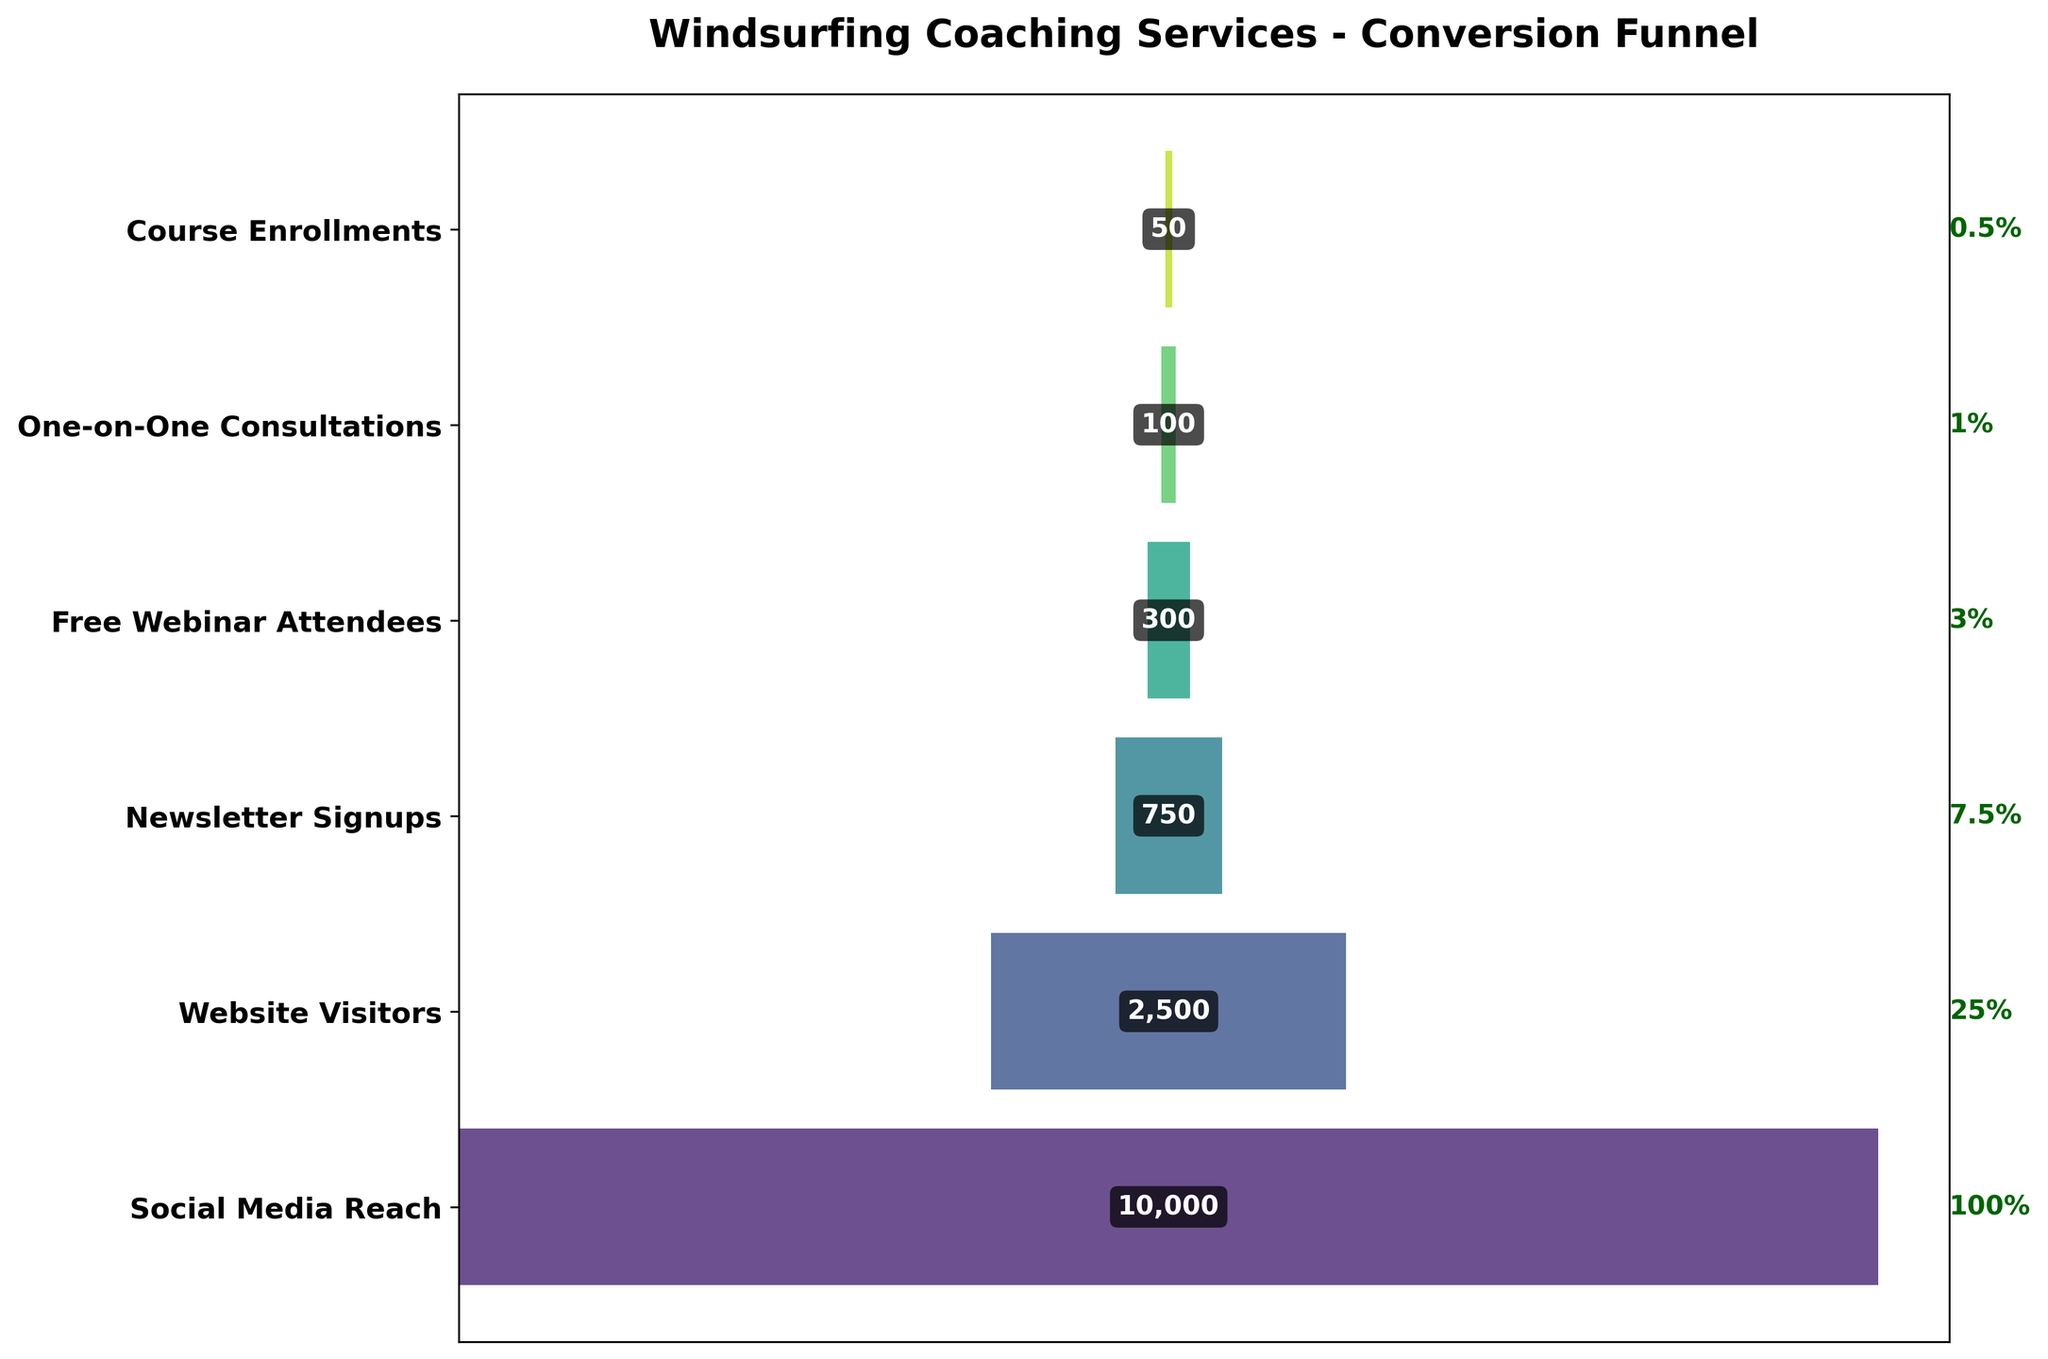What's the total number of participants at the "Website Visitors" stage? We're looking for the participants labeled at the "Website Visitors" stage. According to the chart, it's 2,500.
Answer: 2,500 What percentage of the social media reach proceeded to "Website Visitors"? "Website Visitors" are 2,500 out of the 10,000 "Social Media Reach". The percentage is calculated as (2,500 / 10,000) * 100 = 25%.
Answer: 25% Which stage has the least participants? By scanning the bar lengths and participant numbers, "Course Enrollments" have the least participants at 50.
Answer: Course Enrollments Compare the conversion rate from "Free Webinar Attendees" to "One-on-One Consultations" with the conversion rate from "Newsletter Signups" to "Free Webinar Attendees". Which is higher? Conversion rate from "Free Webinar Attendees" (300) to "One-on-One Consultations" (100) is 100/300 = 33.33%. From "Newsletter Signups" (750) to "Free Webinar Attendees" (300) is 300/750 = 40%. The latter is higher.
Answer: Newsletter Signups to Free Webinar Attendees What is the approximate drop-off rate between "Website Visitors" and "Newsletter Signups"? The drop-off rate can be found by (1 - (750 / 2,500)) * 100 = 70%.
Answer: 70% How many participants do not progress past the "Free Webinar Attendees" stage? Participants not progressing past this stage include those at the "Free Webinar Attendees" minus "One-on-One Consultations". This is 300 - 100 = 200.
Answer: 200 What's the difference in the number of participants between "Website Visitors" and "Free Webinar Attendees"? Subtracting "Free Webinar Attendees" (300) from "Website Visitors" (2,500) gives us 2,500 - 300 = 2,200.
Answer: 2,200 What conversion stage sees a drop below 1,000 participants for the first time? "Newsletter Signups" are the first stage to drop below 1,000 with 750 participants.
Answer: Newsletter Signups What is the title of the funnel chart? The title is located at the top of the chart and reads "Windsurfing Coaching Services - Conversion Funnel".
Answer: Windsurfing Coaching Services - Conversion Funnel Which stage has a conversion rate of 0.5%? Scanning the conversion rate labels, "Course Enrollments" has a 0.5% rate.
Answer: Course Enrollments 